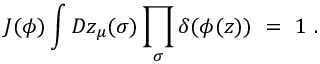Convert formula to latex. <formula><loc_0><loc_0><loc_500><loc_500>J ( \phi ) \int D z _ { \mu } ( \sigma ) \prod _ { \sigma } \delta ( \phi ( z ) ) \ = \ 1 \ .</formula> 